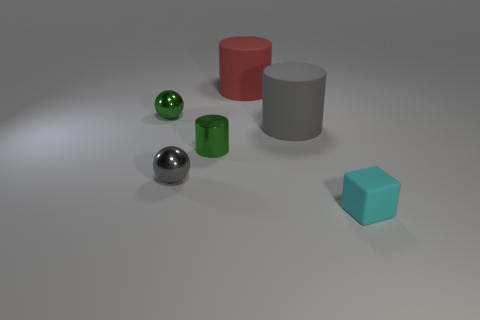Is there a green metallic thing of the same shape as the big gray rubber thing?
Your answer should be very brief. Yes. There is a sphere that is the same color as the tiny shiny cylinder; what is its material?
Make the answer very short. Metal. Are the tiny cyan cube and the big gray thing made of the same material?
Ensure brevity in your answer.  Yes. There is a red cylinder; are there any cylinders in front of it?
Offer a very short reply. Yes. What material is the ball in front of the rubber cylinder in front of the green sphere made of?
Provide a succinct answer. Metal. There is a metal thing that is the same shape as the large gray matte object; what is its size?
Offer a terse response. Small. What color is the object that is to the right of the metallic cylinder and in front of the gray matte cylinder?
Your response must be concise. Cyan. Is the size of the gray object on the left side of the red object the same as the large red matte cylinder?
Keep it short and to the point. No. Are there any other things that are the same shape as the cyan matte thing?
Make the answer very short. No. Do the cyan cube and the cylinder left of the big red rubber object have the same material?
Keep it short and to the point. No. 